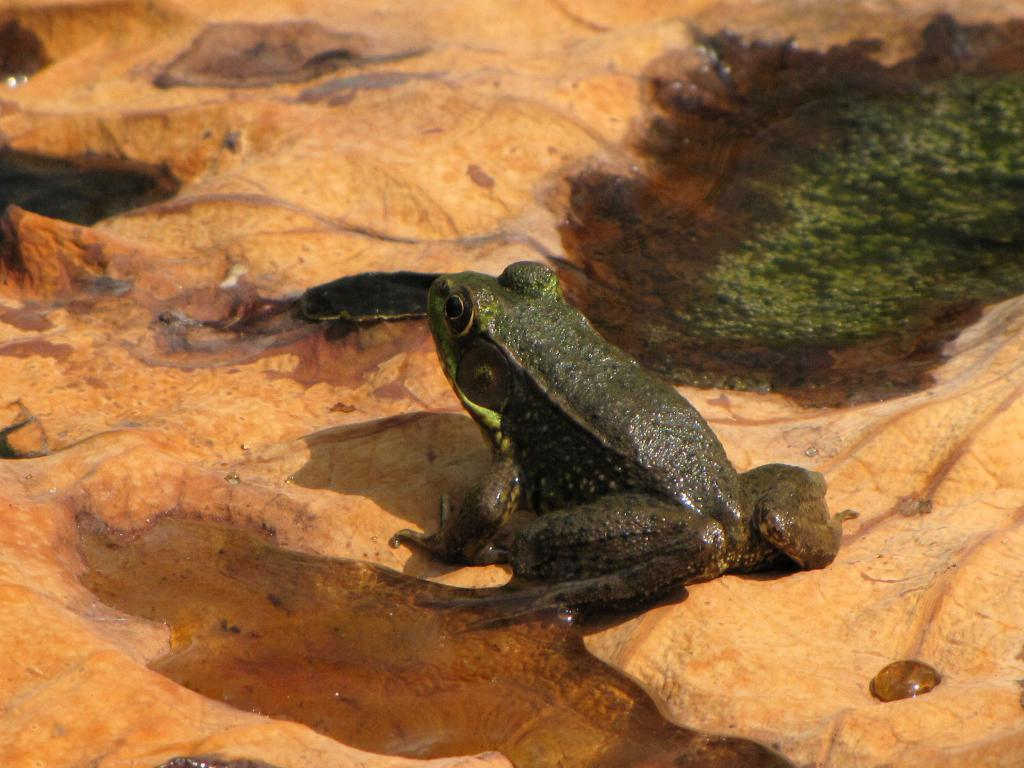What type of animal is in the image? There is a frog in the image. What color is the frog? The frog is green in color. What is the surface the frog is on? The frog is on a brown color surface. What type of heart is visible in the image? There is no heart visible in the image; it features a frog on a brown surface. 